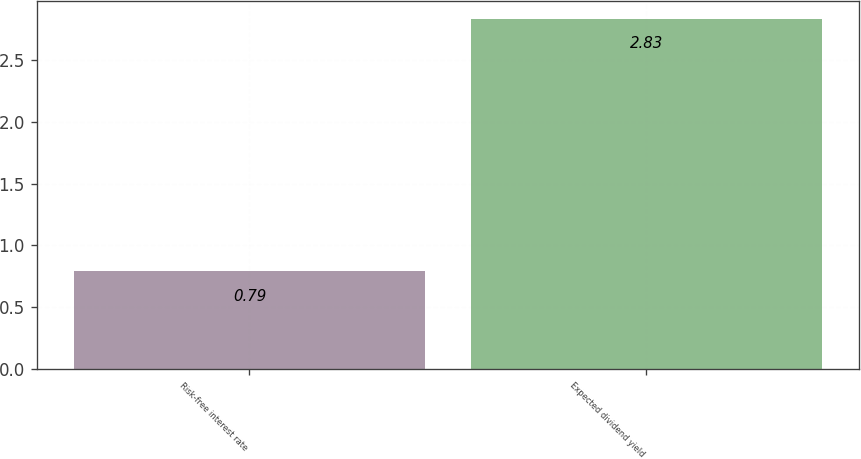Convert chart to OTSL. <chart><loc_0><loc_0><loc_500><loc_500><bar_chart><fcel>Risk-free interest rate<fcel>Expected dividend yield<nl><fcel>0.79<fcel>2.83<nl></chart> 